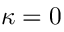Convert formula to latex. <formula><loc_0><loc_0><loc_500><loc_500>\kappa = 0</formula> 